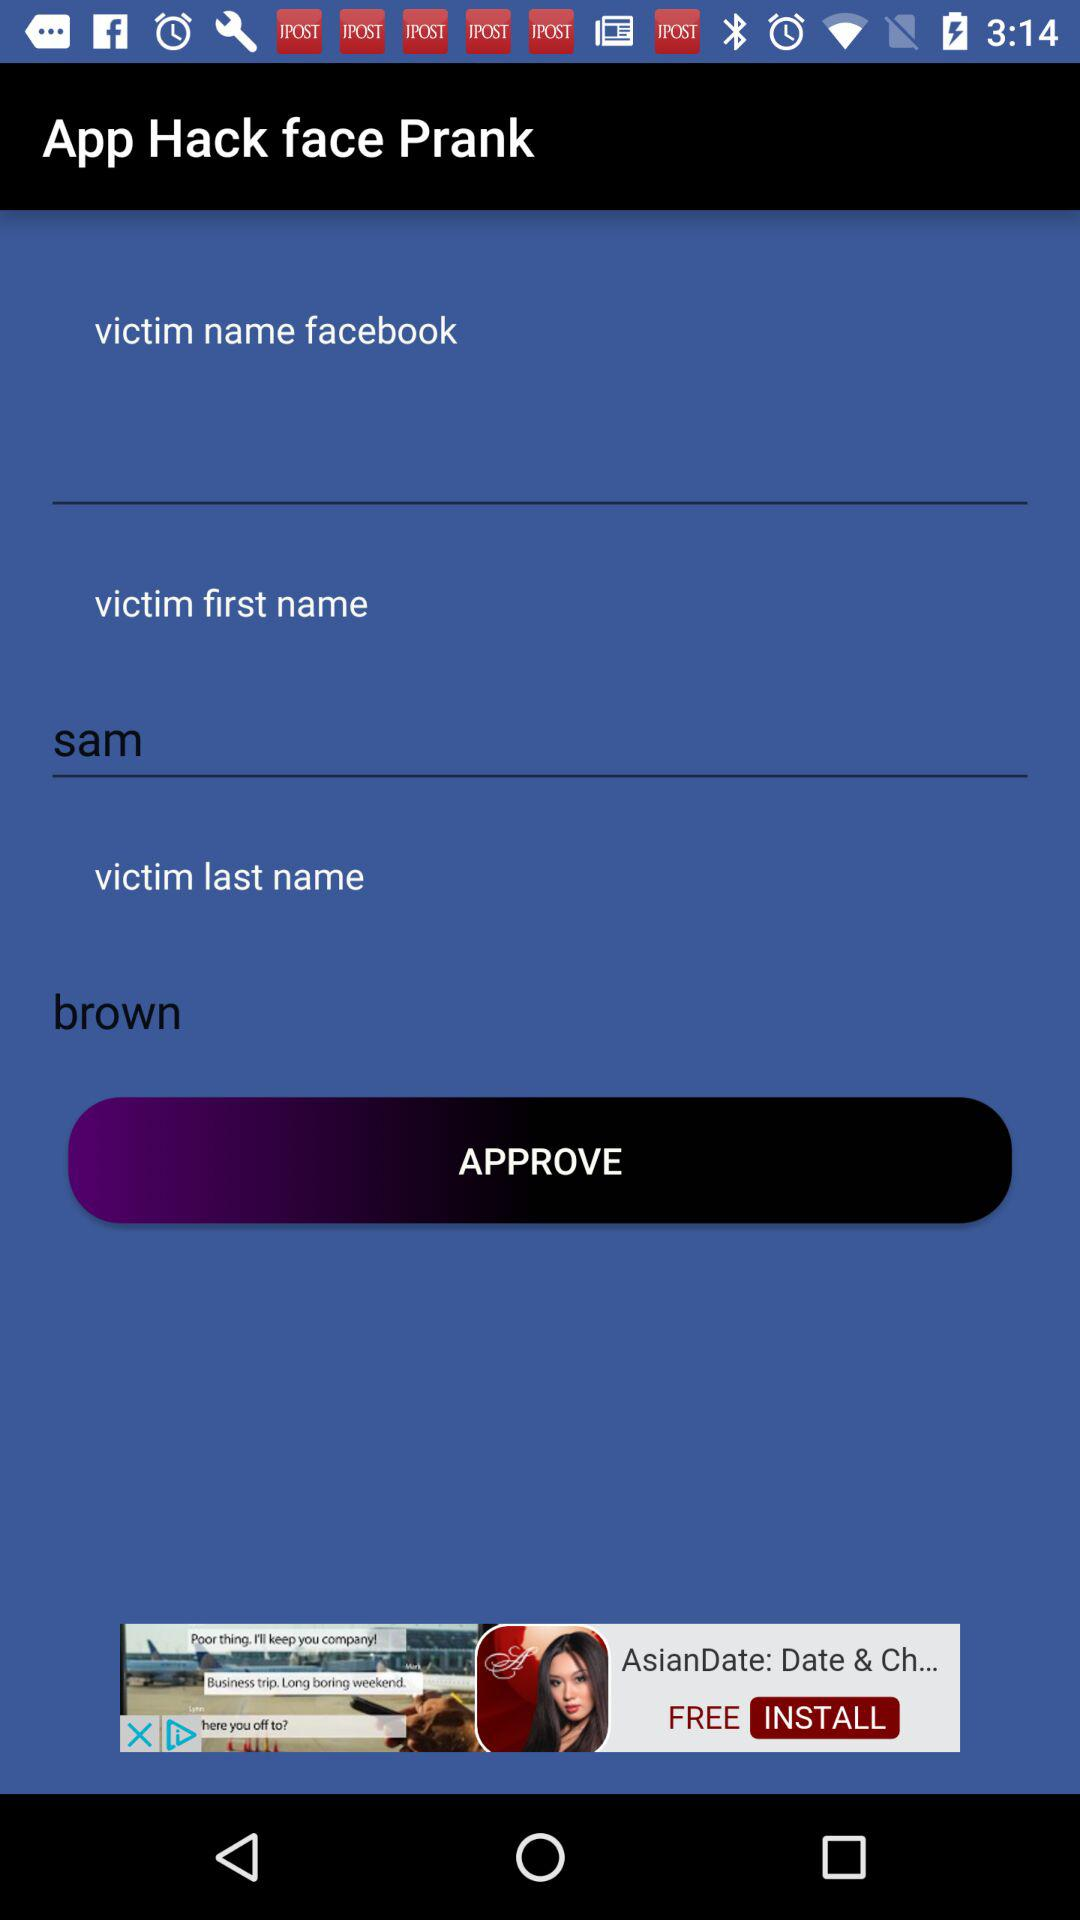What is the victim's first name? The victim's first name is Sam. 